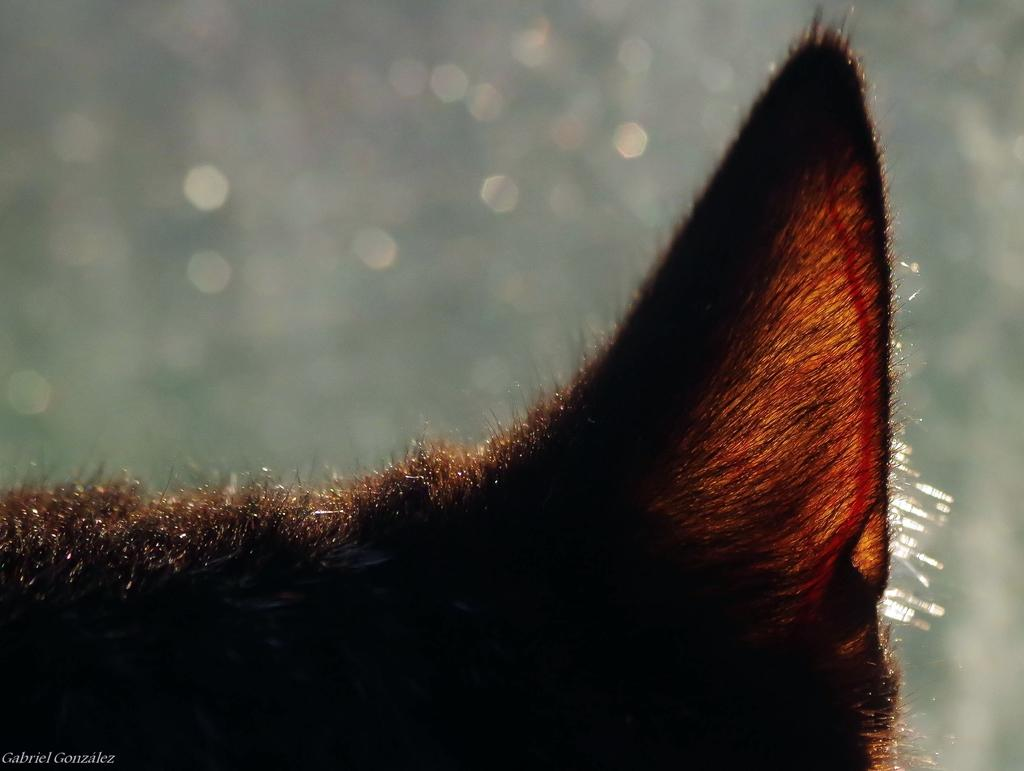What part of an animal can be seen in the image? There is an animal's ear in the image. How would you describe the background of the image? The background is blurred. Where is the text located in the image? The text is in the bottom left corner of the image. What type of light is being emitted from the crow's iron beak in the image? There is no light, crow, or iron being emitted in the image. The image only features an animal's ear, a blurred background, and text in the bottom left corner. 